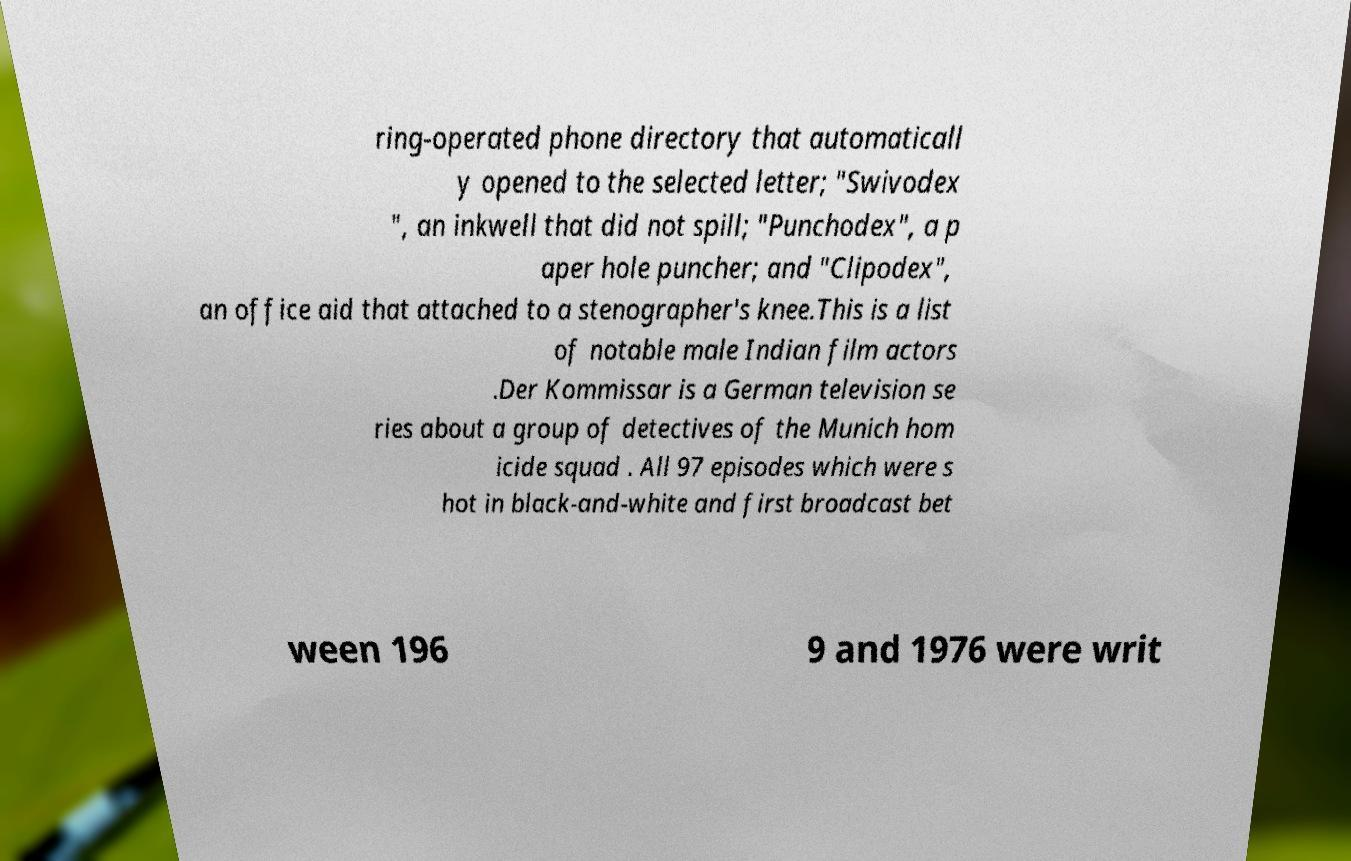There's text embedded in this image that I need extracted. Can you transcribe it verbatim? ring-operated phone directory that automaticall y opened to the selected letter; "Swivodex ", an inkwell that did not spill; "Punchodex", a p aper hole puncher; and "Clipodex", an office aid that attached to a stenographer's knee.This is a list of notable male Indian film actors .Der Kommissar is a German television se ries about a group of detectives of the Munich hom icide squad . All 97 episodes which were s hot in black-and-white and first broadcast bet ween 196 9 and 1976 were writ 